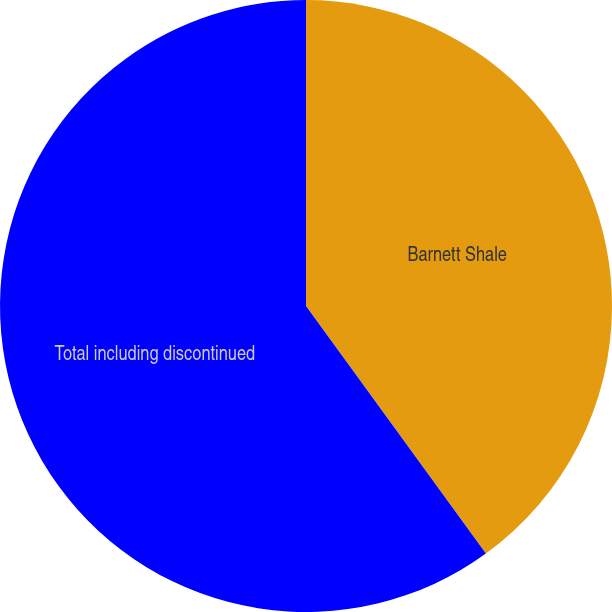<chart> <loc_0><loc_0><loc_500><loc_500><pie_chart><fcel>Barnett Shale<fcel>Total including discontinued<nl><fcel>40.0%<fcel>60.0%<nl></chart> 